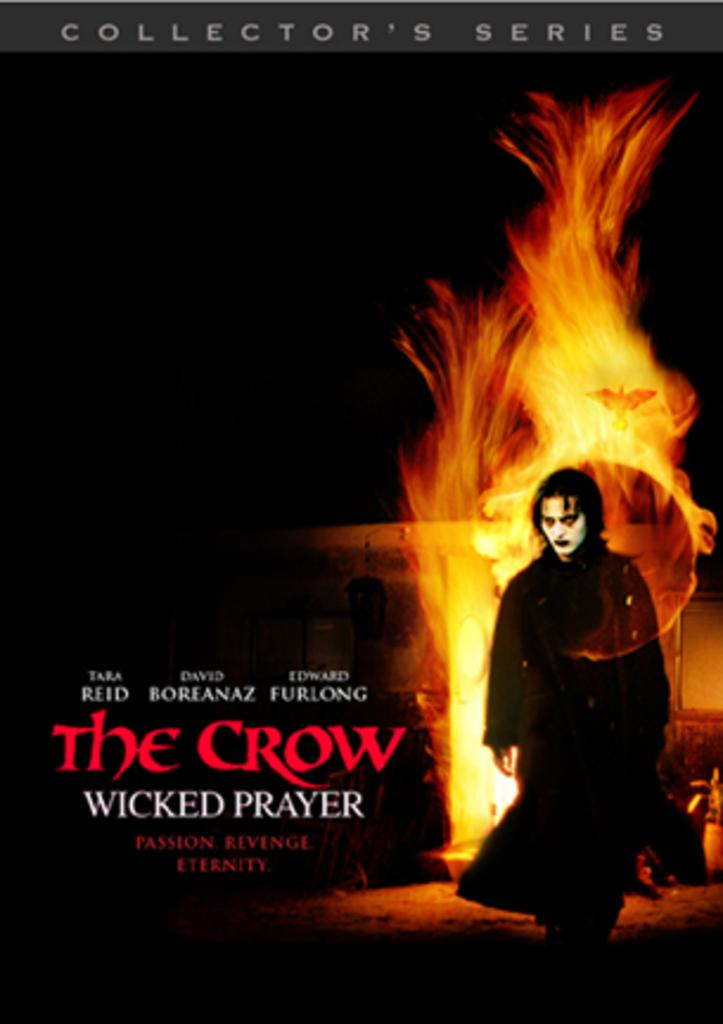<image>
Give a short and clear explanation of the subsequent image. The Crow Wicked Prayer is a movie starring Tara Reid, David Boreanaz and Edward Furlong 